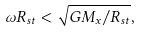<formula> <loc_0><loc_0><loc_500><loc_500>\omega R _ { s t } < \sqrt { G M _ { x } / R _ { s t } } ,</formula> 